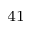<formula> <loc_0><loc_0><loc_500><loc_500>^ { 4 1 }</formula> 